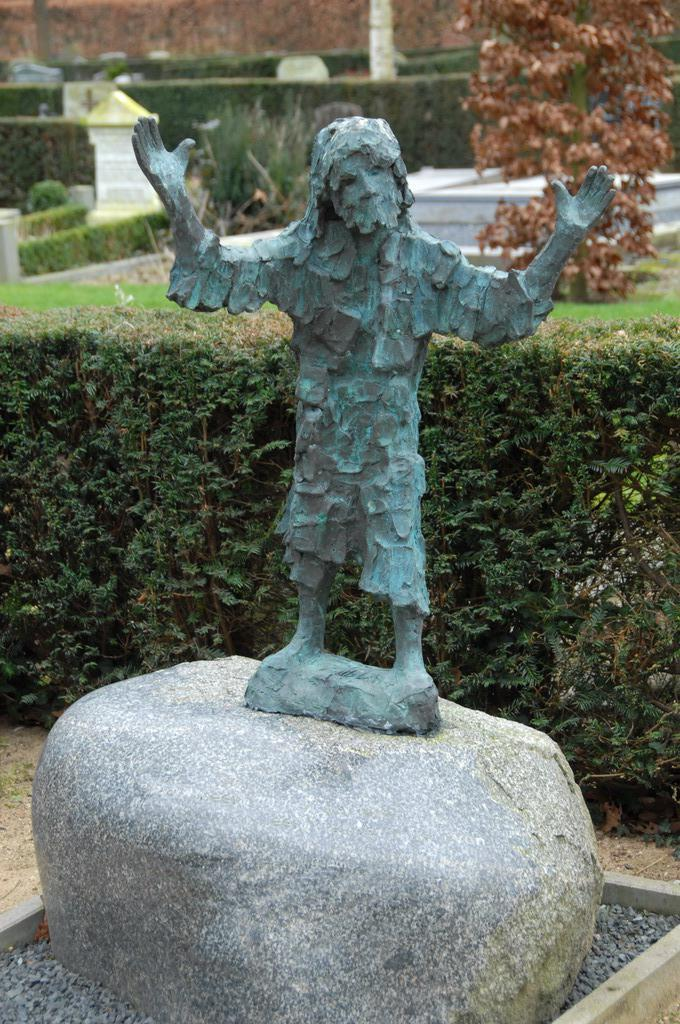What is the main subject of the image? There is a sculpture of a person standing in the image. What materials can be seen in the image? There are stones, plants, grass, and trees in the image. How would you describe the setting of the image? The image features a sculpture surrounded by natural elements such as plants, grass, and trees. What is the quality of the background in the image? The background of the image is slightly blurred. What type of oatmeal is being served at the event in the image? There is no event or oatmeal present in the image; it features a sculpture surrounded by natural elements. How does the sculpture show respect to the trees in the image? The sculpture is a static object and does not display emotions or actions, so it cannot show respect to the trees. 